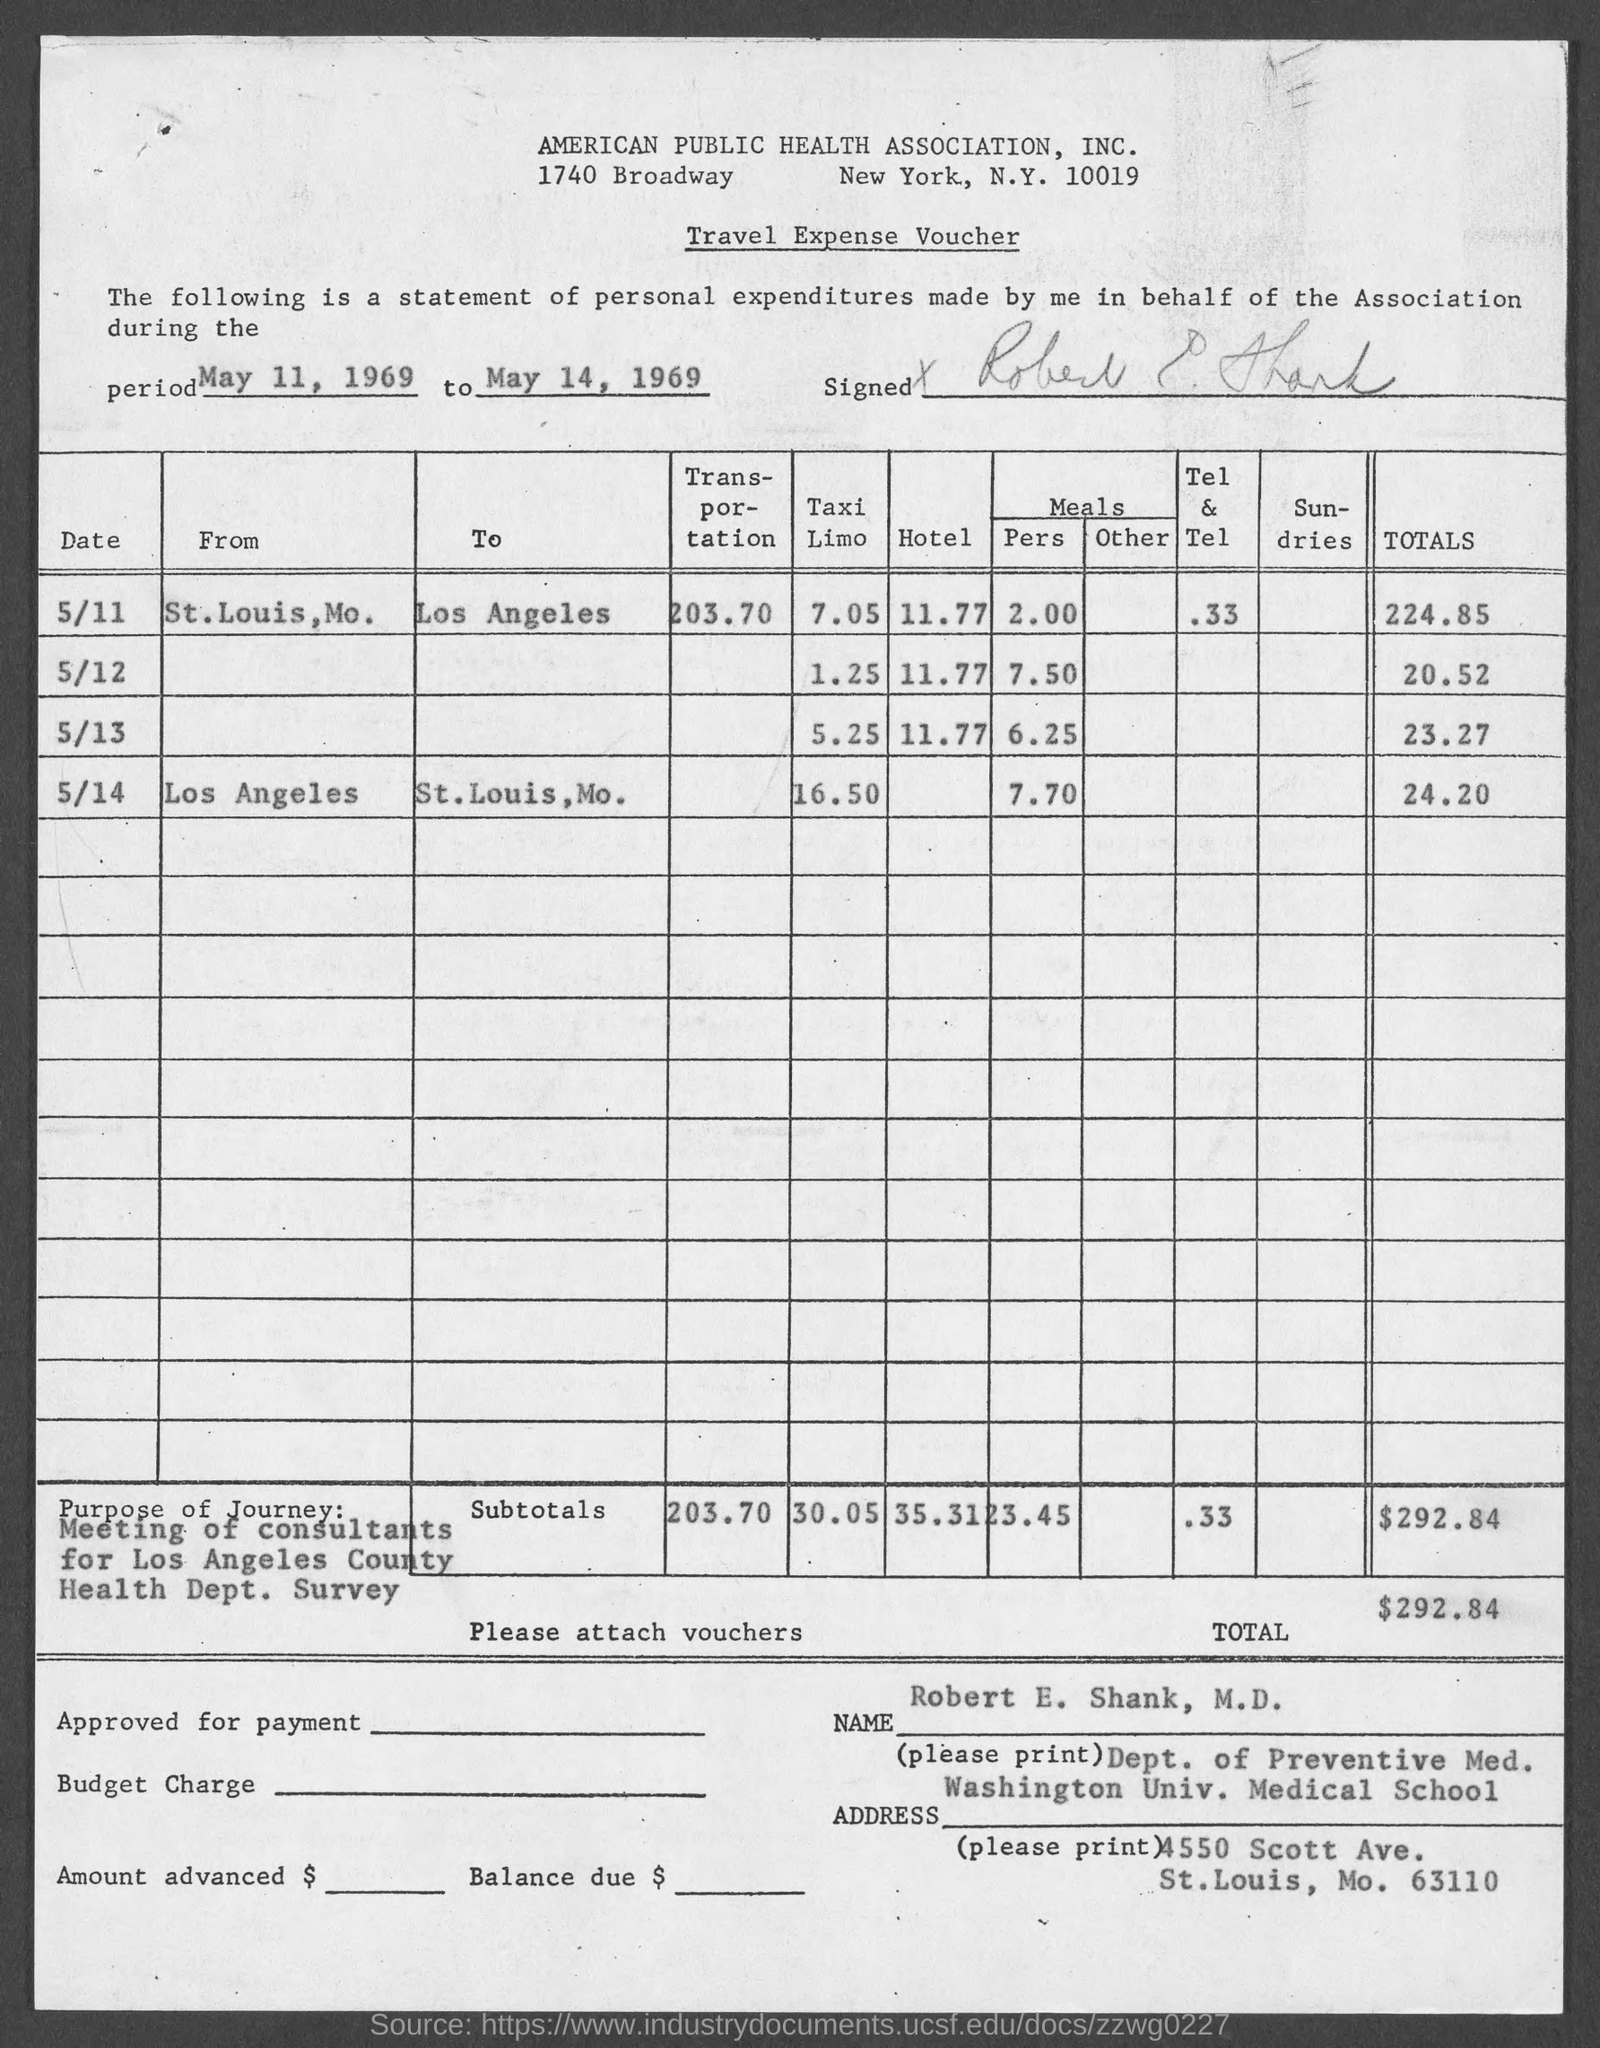Highlight a few significant elements in this photo. The total amount is $292.84, including any applicable fees and taxes. The period of personal expenditure stated is from May 11, 1969 to May 14, 1969. The address of the American Public Health Association, Inc. is 1740 Broadway, New York, New York 10019. 